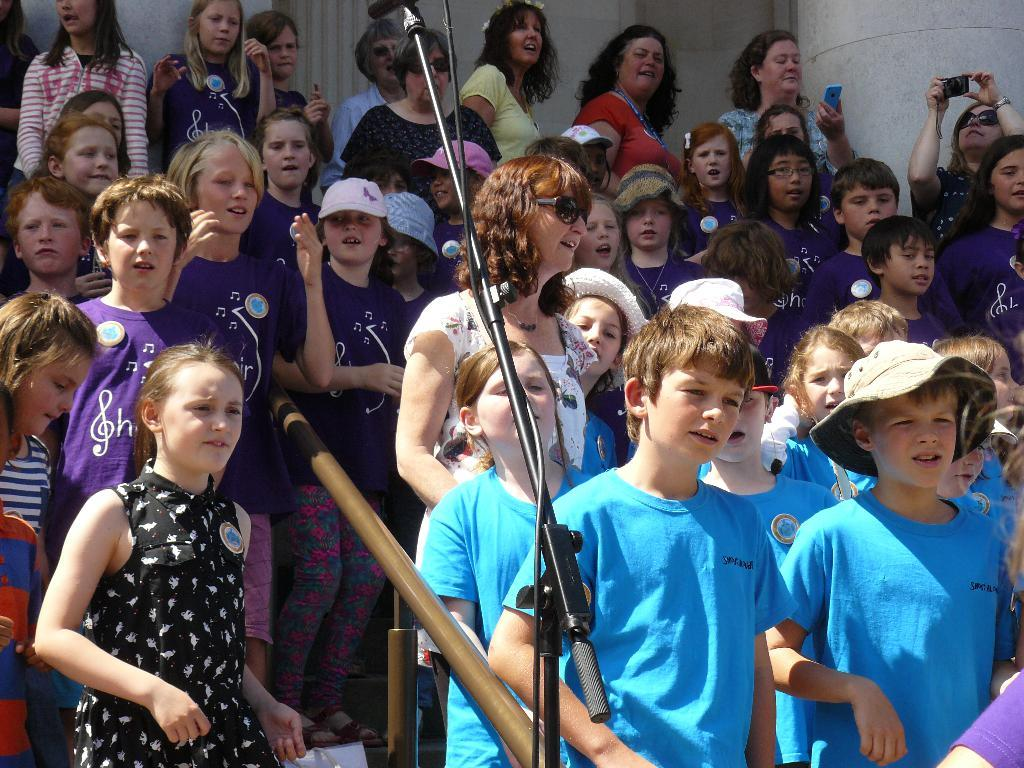What types of individuals can be seen in the image? There are children and people in the image. What objects are present in the image? There are rods, a mic stand, cables, and other objects in the image. What are some people doing in the image? Some people are holding objects, and some are wearing caps. What can be seen in the background of the image? There is a wall in the image. What flavor of ice cream are the boys eating in the image? There is no ice cream present in the image, and no boys are mentioned. 